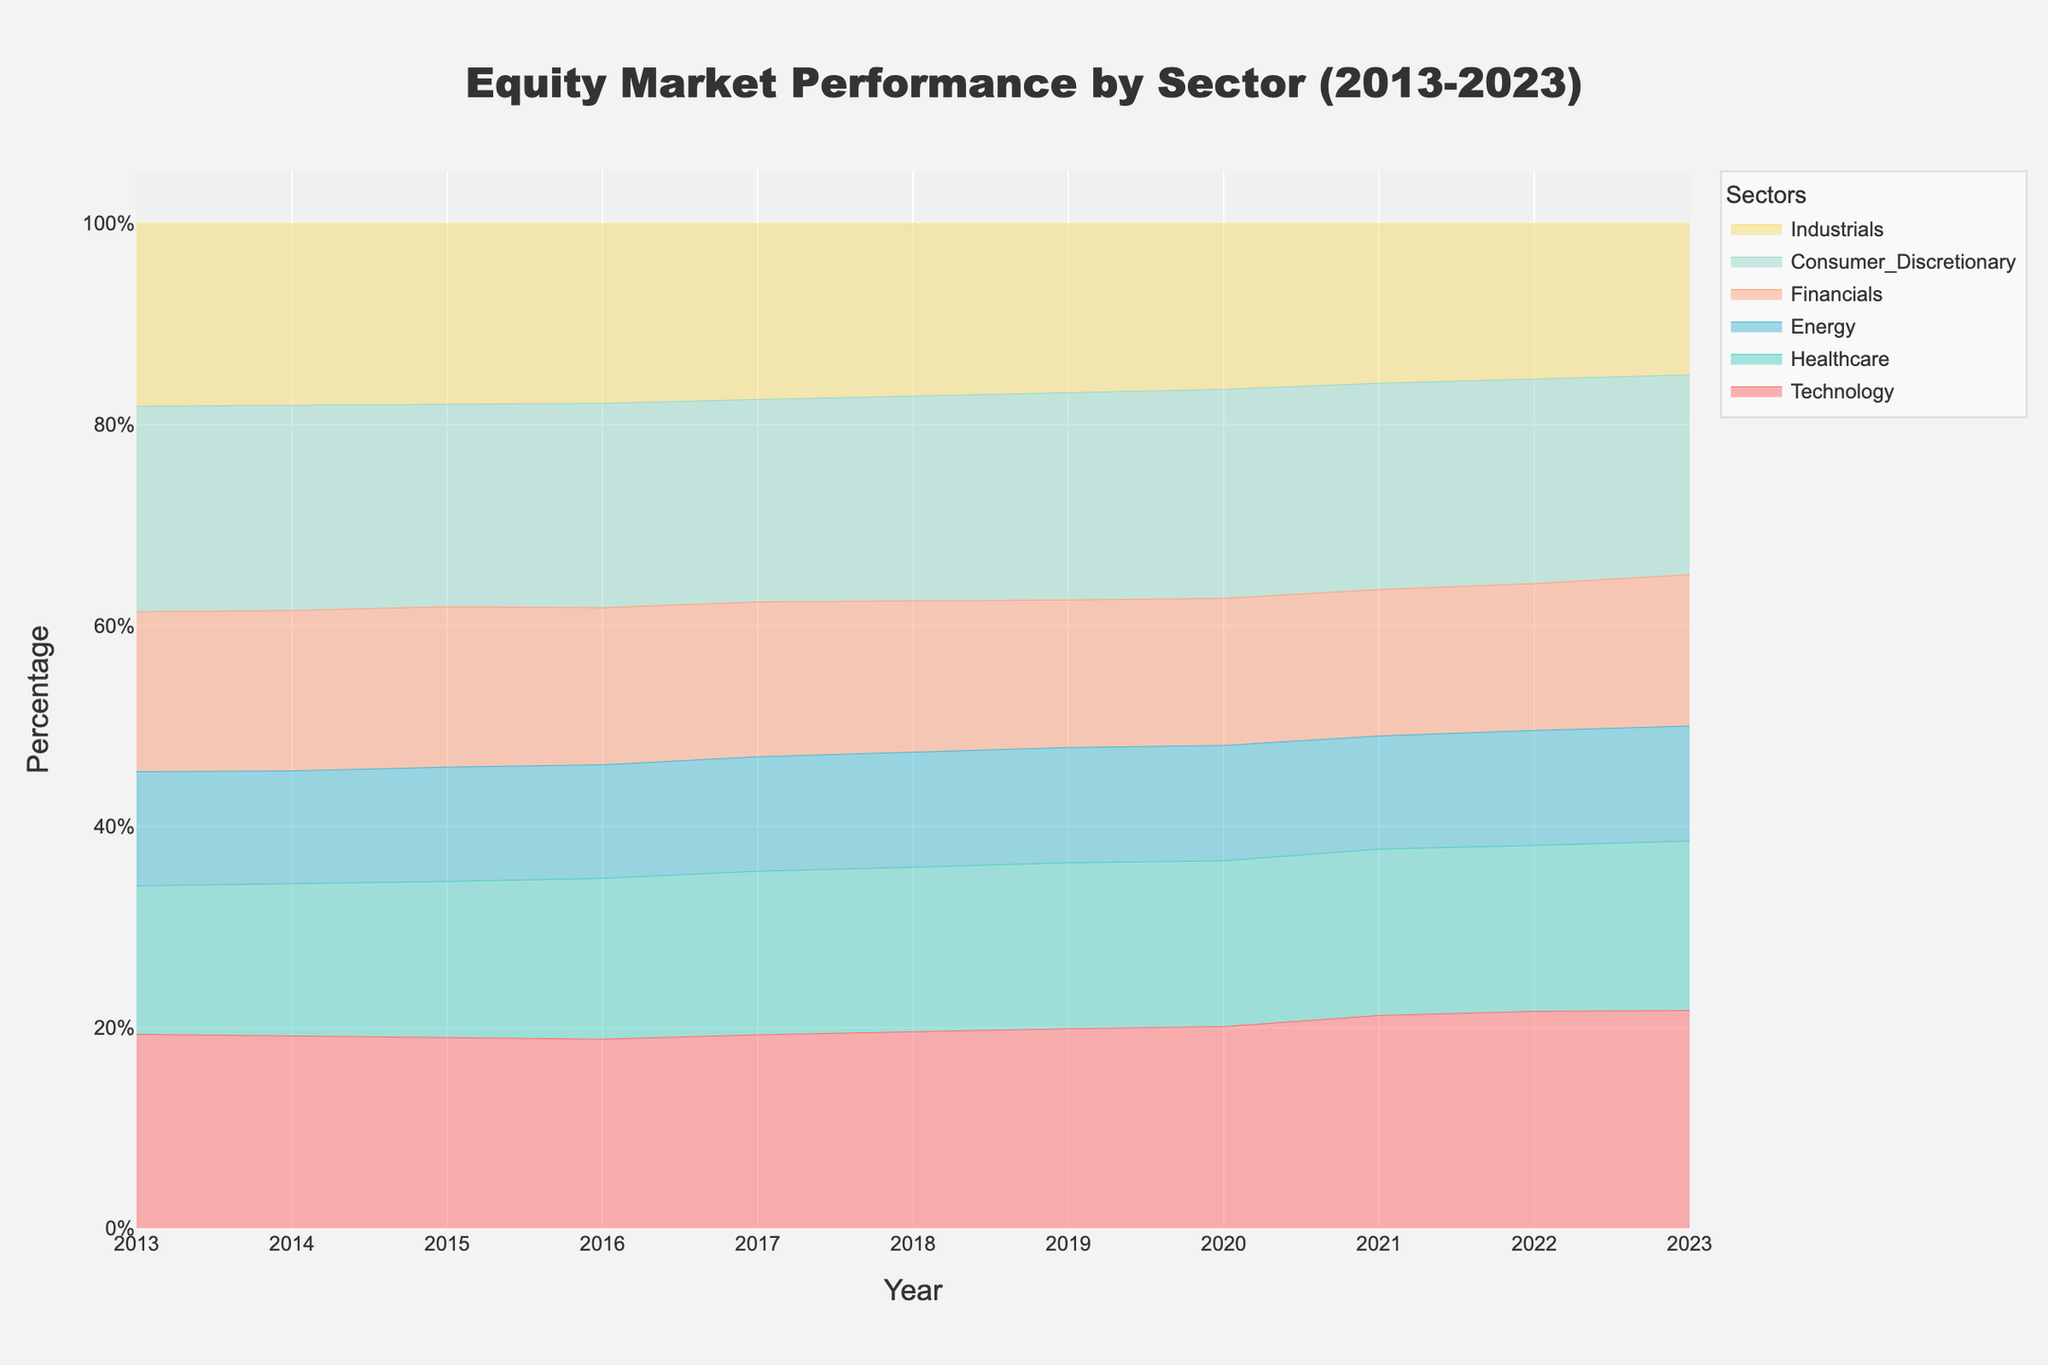What sectors are depicted in the area chart? The chart includes several industry sectors represented by different colored areas. These sectors are indicated in the legend.
Answer: Technology, Healthcare, Energy, Financials, Consumer Discretionary, Industrials What is the range of years shown in the chart? The horizontal axis (x-axis) represents the years. The range is from the first year to the last year indicated on the x-axis.
Answer: 2013-2023 Which sector appears to have the highest percent composition in 2023? The topmost section in 2023 represents the sector with the highest percent composition. The legend indicates which color corresponds to each sector.
Answer: Technology How did the Financials sector performance change from 2013 to 2023? Look at the area corresponding to Financials at the start (2013) and at the end (2023) of the chart. Compare the relative height or the percentage it occupies.
Answer: It increased Which sector shows a significant increase around 2020? Identify the sector that shows a noticeable rise in its area around the year 2020. Use the legend to determine which sector corresponds to which color.
Answer: Technology What is the difference in percentage composition between the Healthcare and Energy sectors in 2023? Look at the vertical heights of the areas corresponding to Healthcare and Energy in 2023. Calculate the difference in those percentages. The colors corresponding to these sectors are found in the legend.
Answer: Approximately 9% Which sector had the smallest percentage share in 2018? Identify the sector with the smallest area in that year. The legend helps in recognizing the colors corresponding to each sector.
Answer: Energy How has the Consumer Discretionary sector's performance trended over the evaluated years? Track the area corresponding to Consumer Discretionary across the years from 2013 to 2023 to see the general trend.
Answer: It has increased Which two sectors have shown the closest competition in terms of percentage composition over the observed period? Compare the areas of each sector over the years. Identify which two sectors have areas that are closest in size for most of the period between 2013 and 2023.
Answer: Technology and Healthcare Using the colors in the chart, which sector's performance looks relatively stable over the years? Identify the sector whose color area remains relatively unchanged in its percentage composition from 2013 to 2023.
Answer: Industrials 